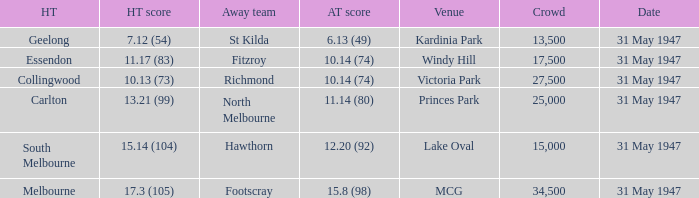What is the listed crowd when hawthorn is away? 1.0. 